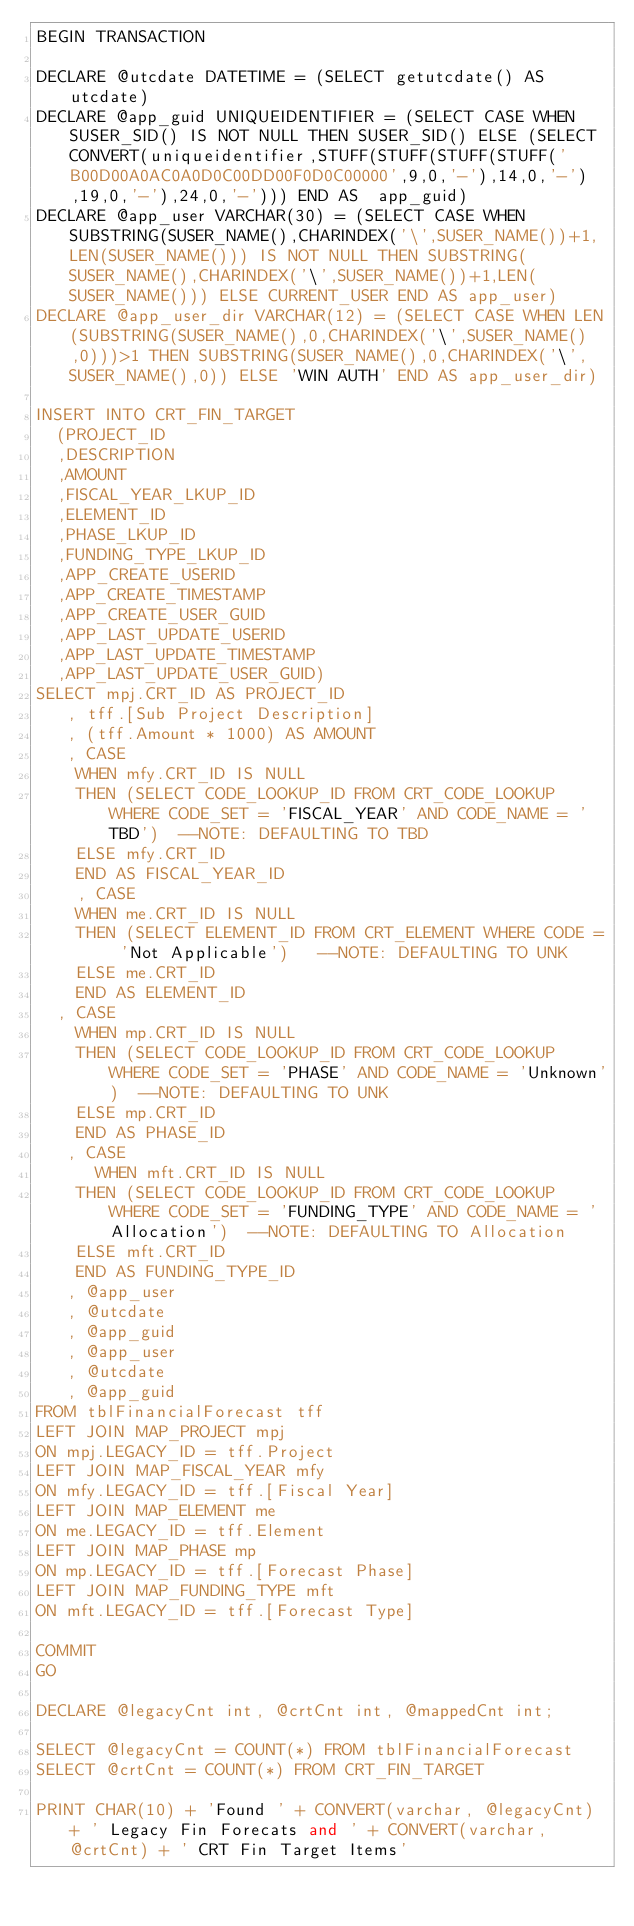Convert code to text. <code><loc_0><loc_0><loc_500><loc_500><_SQL_>BEGIN TRANSACTION 

DECLARE @utcdate DATETIME = (SELECT getutcdate() AS utcdate)
DECLARE @app_guid UNIQUEIDENTIFIER = (SELECT CASE WHEN SUSER_SID() IS NOT NULL THEN SUSER_SID() ELSE (SELECT CONVERT(uniqueidentifier,STUFF(STUFF(STUFF(STUFF('B00D00A0AC0A0D0C00DD00F0D0C00000',9,0,'-'),14,0,'-'),19,0,'-'),24,0,'-'))) END AS  app_guid)
DECLARE @app_user VARCHAR(30) = (SELECT CASE WHEN SUBSTRING(SUSER_NAME(),CHARINDEX('\',SUSER_NAME())+1,LEN(SUSER_NAME())) IS NOT NULL THEN SUBSTRING(SUSER_NAME(),CHARINDEX('\',SUSER_NAME())+1,LEN(SUSER_NAME())) ELSE CURRENT_USER END AS app_user)
DECLARE @app_user_dir VARCHAR(12) = (SELECT CASE WHEN LEN(SUBSTRING(SUSER_NAME(),0,CHARINDEX('\',SUSER_NAME(),0)))>1 THEN SUBSTRING(SUSER_NAME(),0,CHARINDEX('\',SUSER_NAME(),0)) ELSE 'WIN AUTH' END AS app_user_dir)

INSERT INTO CRT_FIN_TARGET 
	(PROJECT_ID
	,DESCRIPTION
	,AMOUNT
	,FISCAL_YEAR_LKUP_ID
	,ELEMENT_ID
	,PHASE_LKUP_ID
	,FUNDING_TYPE_LKUP_ID
	,APP_CREATE_USERID
	,APP_CREATE_TIMESTAMP
	,APP_CREATE_USER_GUID
	,APP_LAST_UPDATE_USERID
	,APP_LAST_UPDATE_TIMESTAMP
	,APP_LAST_UPDATE_USER_GUID)
SELECT mpj.CRT_ID AS PROJECT_ID
	 , tff.[Sub Project Description]
	 , (tff.Amount * 1000) AS AMOUNT
	 , CASE
		WHEN mfy.CRT_ID IS NULL 
		THEN (SELECT CODE_LOOKUP_ID FROM CRT_CODE_LOOKUP WHERE CODE_SET = 'FISCAL_YEAR' AND CODE_NAME = 'TBD')	--NOTE: DEFAULTING TO TBD
		ELSE mfy.CRT_ID
		END AS FISCAL_YEAR_ID
	  , CASE 
		WHEN me.CRT_ID IS NULL 
		THEN (SELECT ELEMENT_ID FROM CRT_ELEMENT WHERE CODE = 'Not Applicable') 	--NOTE: DEFAULTING TO UNK
		ELSE me.CRT_ID 
		END AS ELEMENT_ID
	, CASE	
		WHEN mp.CRT_ID IS NULL
		THEN (SELECT CODE_LOOKUP_ID FROM CRT_CODE_LOOKUP WHERE CODE_SET = 'PHASE' AND CODE_NAME = 'Unknown') 	--NOTE: DEFAULTING TO UNK
		ELSE mp.CRT_ID
		END AS PHASE_ID
	 , CASE	
	    WHEN mft.CRT_ID IS NULL
		THEN (SELECT CODE_LOOKUP_ID FROM CRT_CODE_LOOKUP WHERE CODE_SET = 'FUNDING_TYPE' AND CODE_NAME = 'Allocation') 	--NOTE: DEFAULTING TO Allocation
		ELSE mft.CRT_ID
		END AS FUNDING_TYPE_ID
	 , @app_user
	 , @utcdate
	 , @app_guid
	 , @app_user
	 , @utcdate
	 , @app_guid
FROM tblFinancialForecast tff
LEFT JOIN MAP_PROJECT mpj
ON mpj.LEGACY_ID = tff.Project
LEFT JOIN MAP_FISCAL_YEAR mfy
ON mfy.LEGACY_ID = tff.[Fiscal Year]
LEFT JOIN MAP_ELEMENT me
ON me.LEGACY_ID = tff.Element
LEFT JOIN MAP_PHASE mp
ON mp.LEGACY_ID = tff.[Forecast Phase]
LEFT JOIN MAP_FUNDING_TYPE mft
ON mft.LEGACY_ID = tff.[Forecast Type]

COMMIT
GO

DECLARE @legacyCnt int, @crtCnt int, @mappedCnt int;

SELECT @legacyCnt = COUNT(*) FROM tblFinancialForecast
SELECT @crtCnt = COUNT(*) FROM CRT_FIN_TARGET

PRINT CHAR(10) + 'Found ' + CONVERT(varchar, @legacyCnt) + ' Legacy Fin Forecats and ' + CONVERT(varchar, @crtCnt) + ' CRT Fin Target Items'

</code> 